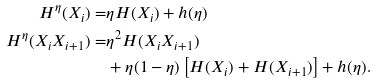<formula> <loc_0><loc_0><loc_500><loc_500>H ^ { \eta } ( X _ { i } ) = & \eta H ( X _ { i } ) + h ( \eta ) \\ H ^ { \eta } ( X _ { i } X _ { i + 1 } ) = & \eta ^ { 2 } H ( X _ { i } X _ { i + 1 } ) \\ & + \eta ( 1 - \eta ) \left [ H ( X _ { i } ) + H ( X _ { i + 1 } ) \right ] + h ( \eta ) .</formula> 